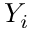Convert formula to latex. <formula><loc_0><loc_0><loc_500><loc_500>Y _ { i }</formula> 